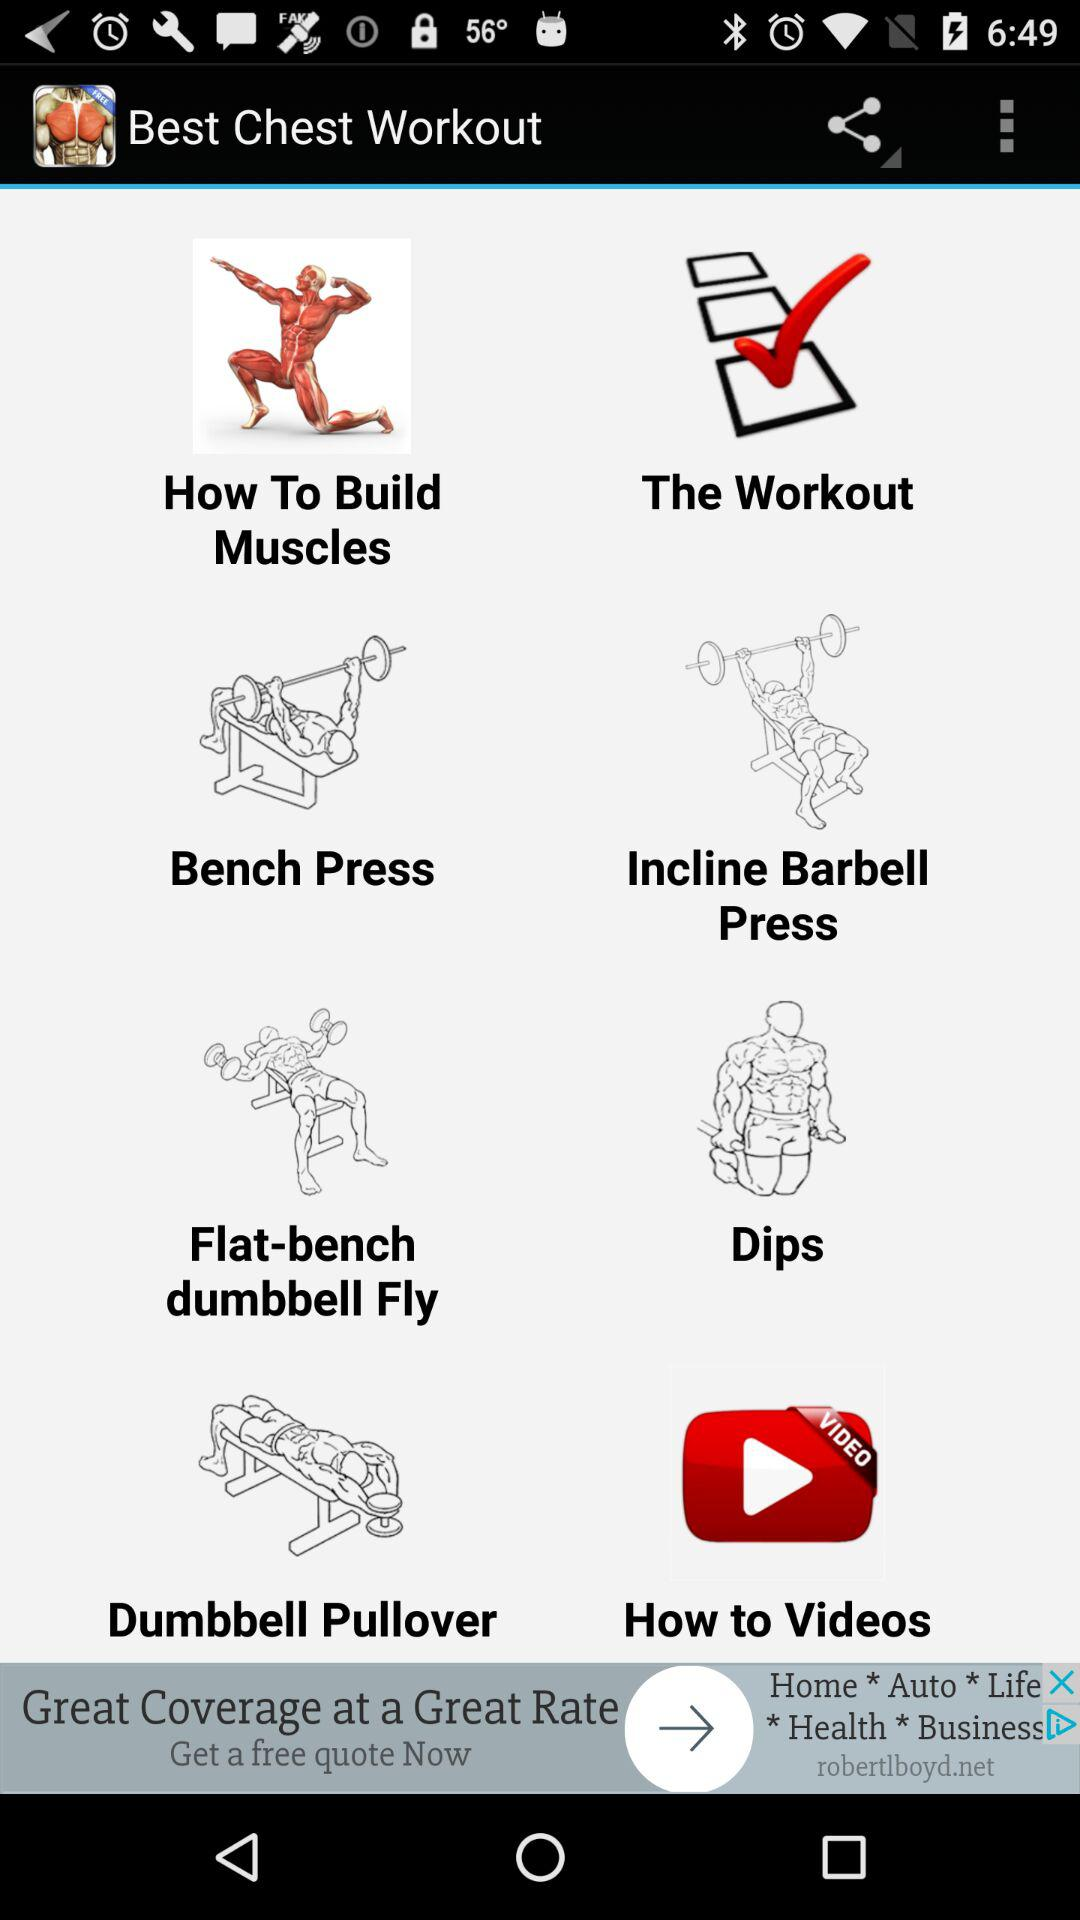Through which applications can this be shared?
When the provided information is insufficient, respond with <no answer>. <no answer> 